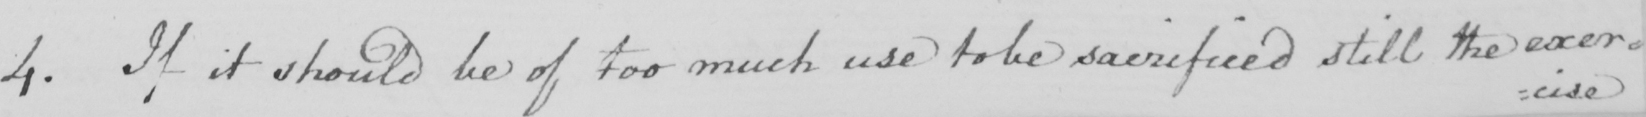Please transcribe the handwritten text in this image. 4 . If it should be of too much use to be sacrificed still the exer= 